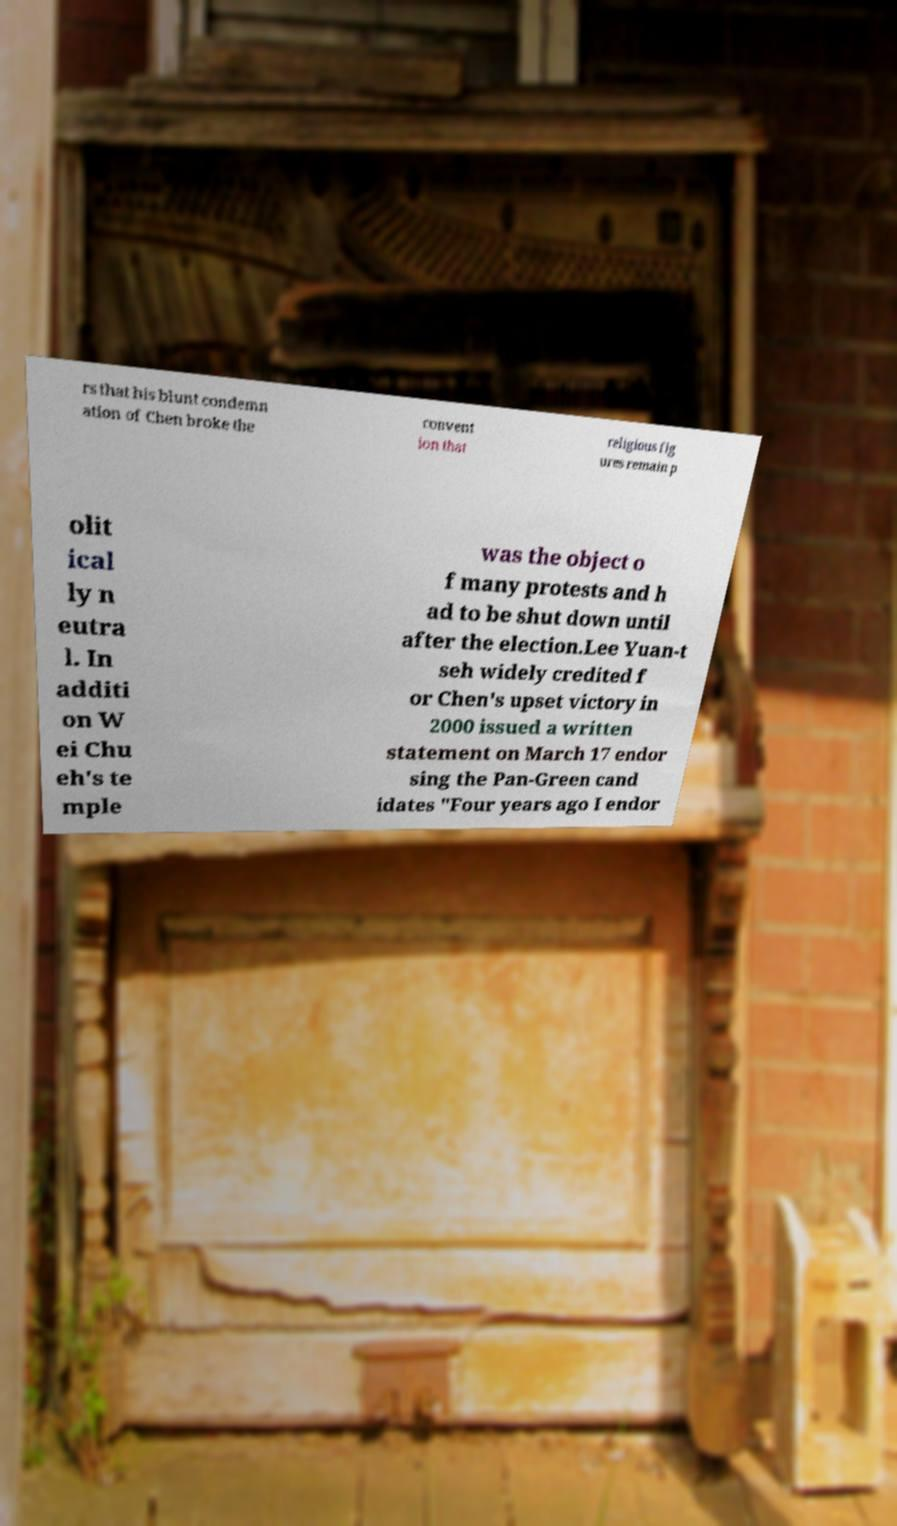Could you extract and type out the text from this image? rs that his blunt condemn ation of Chen broke the convent ion that religious fig ures remain p olit ical ly n eutra l. In additi on W ei Chu eh's te mple was the object o f many protests and h ad to be shut down until after the election.Lee Yuan-t seh widely credited f or Chen's upset victory in 2000 issued a written statement on March 17 endor sing the Pan-Green cand idates "Four years ago I endor 